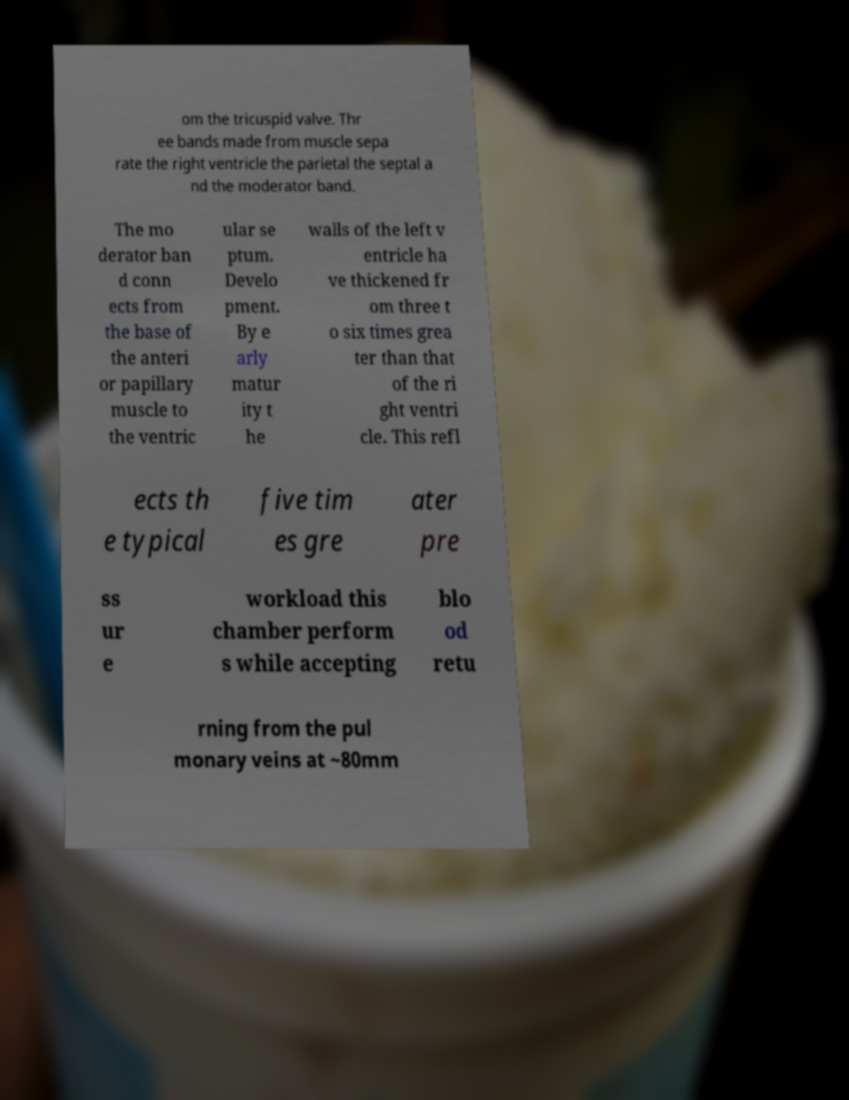What messages or text are displayed in this image? I need them in a readable, typed format. om the tricuspid valve. Thr ee bands made from muscle sepa rate the right ventricle the parietal the septal a nd the moderator band. The mo derator ban d conn ects from the base of the anteri or papillary muscle to the ventric ular se ptum. Develo pment. By e arly matur ity t he walls of the left v entricle ha ve thickened fr om three t o six times grea ter than that of the ri ght ventri cle. This refl ects th e typical five tim es gre ater pre ss ur e workload this chamber perform s while accepting blo od retu rning from the pul monary veins at ~80mm 